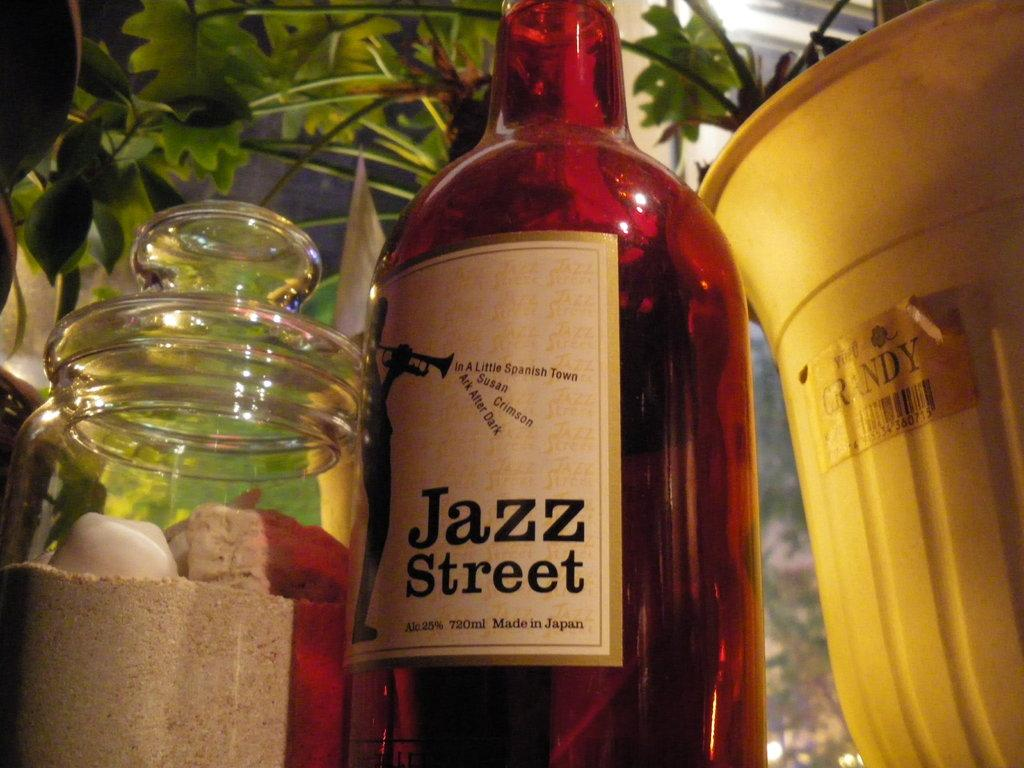<image>
Describe the image concisely. A bottle of Jazz Street that was made in Japan. 